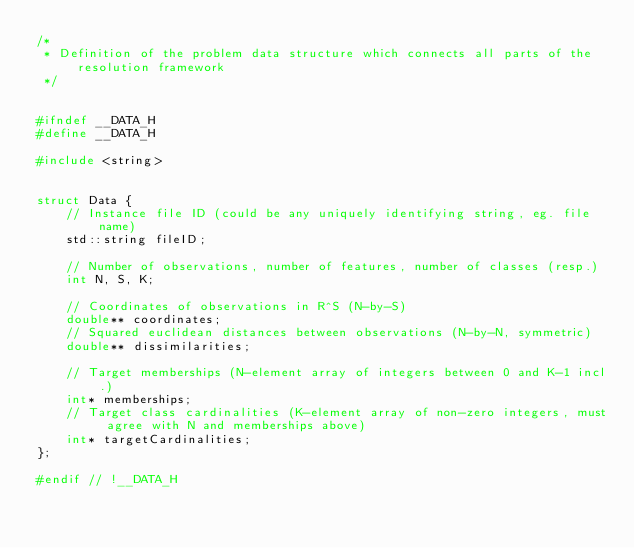<code> <loc_0><loc_0><loc_500><loc_500><_C_>/*
 * Definition of the problem data structure which connects all parts of the resolution framework
 */


#ifndef __DATA_H
#define __DATA_H

#include <string>


struct Data {
    // Instance file ID (could be any uniquely identifying string, eg. file name)
    std::string fileID;

    // Number of observations, number of features, number of classes (resp.)
    int N, S, K;

    // Coordinates of observations in R^S (N-by-S)
    double** coordinates;
    // Squared euclidean distances between observations (N-by-N, symmetric)
    double** dissimilarities;

    // Target memberships (N-element array of integers between 0 and K-1 incl.)
    int* memberships;
    // Target class cardinalities (K-element array of non-zero integers, must agree with N and memberships above)
    int* targetCardinalities;
};

#endif // !__DATA_H</code> 